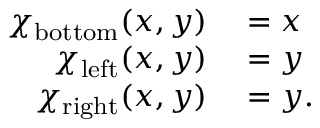Convert formula to latex. <formula><loc_0><loc_0><loc_500><loc_500>\begin{array} { r l } { \chi _ { b o t t o m } ( x , y ) } & = x } \\ { \chi _ { l e f t } ( x , y ) } & = y } \\ { \chi _ { r i g h t } ( x , y ) } & = y . } \end{array}</formula> 